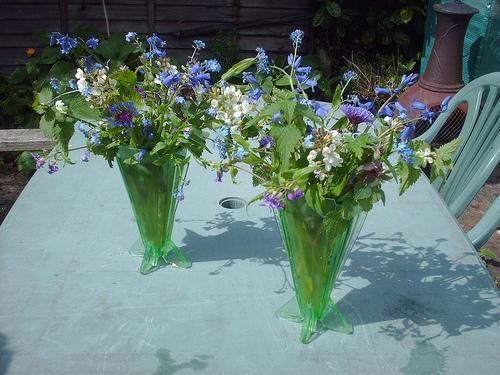How many vases are there?
Give a very brief answer. 2. 